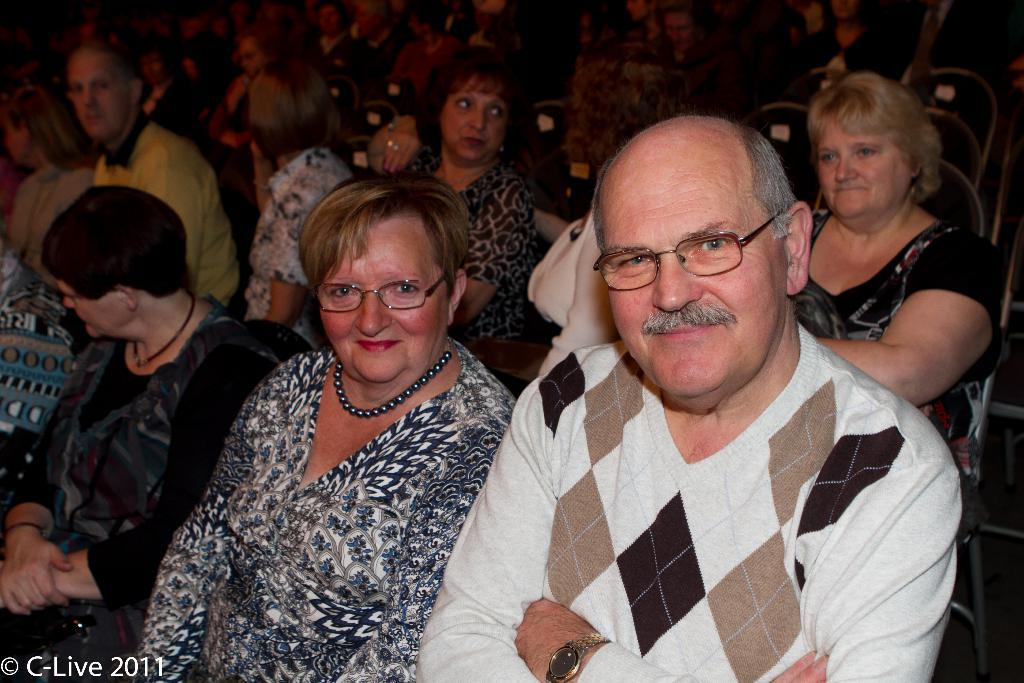How many people are present in the image? There are two people, a woman and a man, present in the image. What are the woman and the man doing in the image? The woman and the man are posing for a camera. What expressions do the woman and the man have in the image? The woman and the man are smiling in the image. What are the woman and the man wearing in the image? The woman and the man are wearing spectacles in the image. What can be seen in the background of the image? There is a group of people sitting in the background of the image. How are the people in the background seated? The people in the background are sitting on chairs. What type of celery can be seen growing in the image? There is no celery present in the image. What type of land can be seen in the image? The image does not depict any land; it features a woman and a man posing for a camera, along with a group of people sitting in the background. 